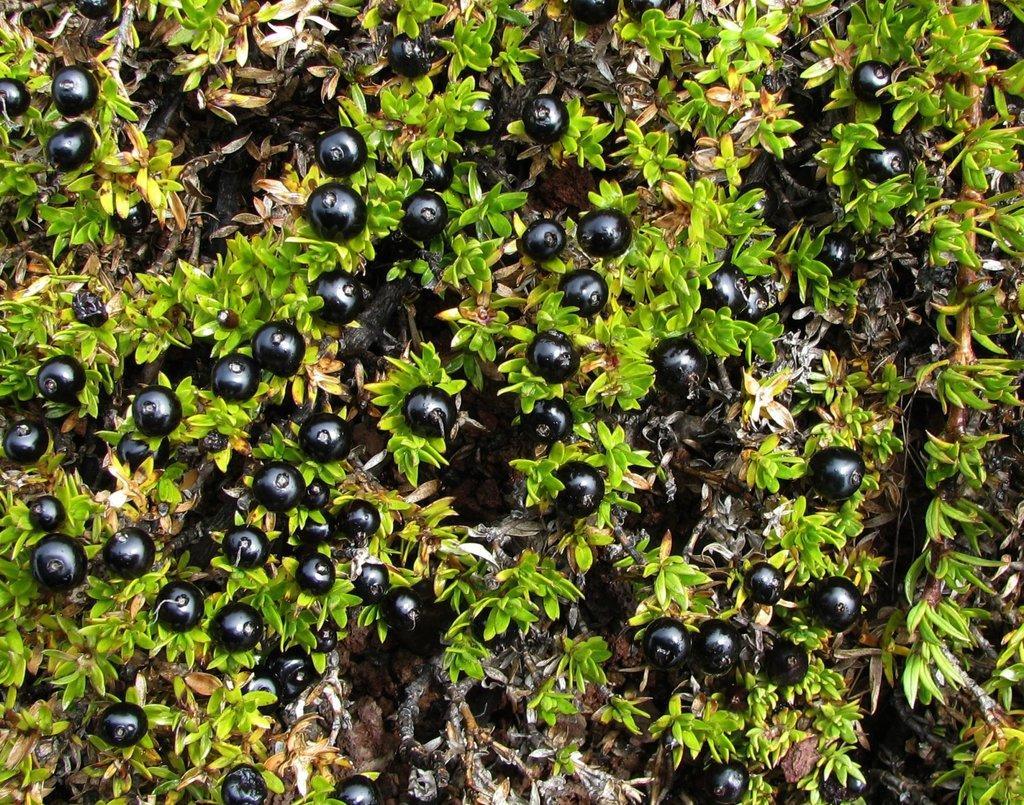Could you give a brief overview of what you see in this image? It seems like there are berries to the plant. 